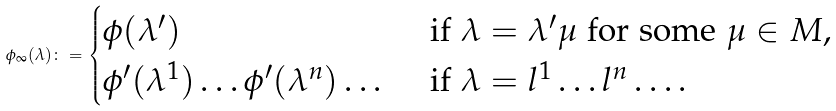Convert formula to latex. <formula><loc_0><loc_0><loc_500><loc_500>\phi _ { \infty } ( \lambda ) \colon = \begin{cases} \phi ( \lambda ^ { \prime } ) & \text { if } \lambda = \lambda ^ { \prime } \mu \text { for some } \mu \in M , \\ \phi ^ { \prime } ( \lambda ^ { 1 } ) \dots \phi ^ { \prime } ( \lambda ^ { n } ) \dots & \text { if } \lambda = l ^ { 1 } \dots l ^ { n } \dots . \end{cases}</formula> 